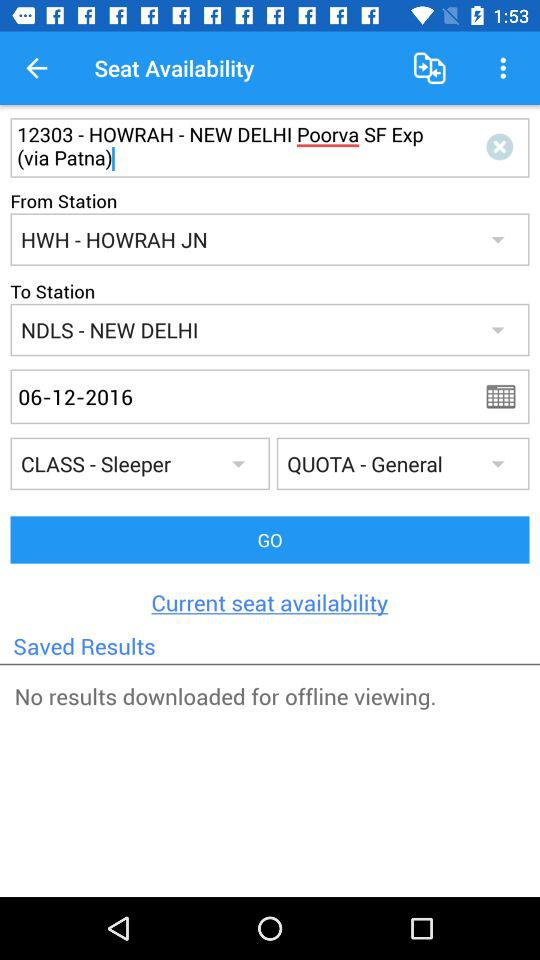What is the destination of the train? The destination of the train is NDLS-New Delhi. 